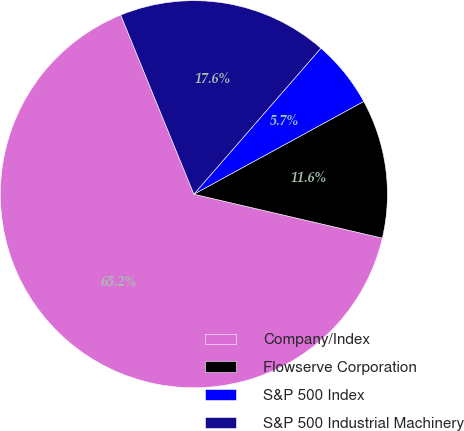Convert chart. <chart><loc_0><loc_0><loc_500><loc_500><pie_chart><fcel>Company/Index<fcel>Flowserve Corporation<fcel>S&P 500 Index<fcel>S&P 500 Industrial Machinery<nl><fcel>65.19%<fcel>11.6%<fcel>5.65%<fcel>17.56%<nl></chart> 